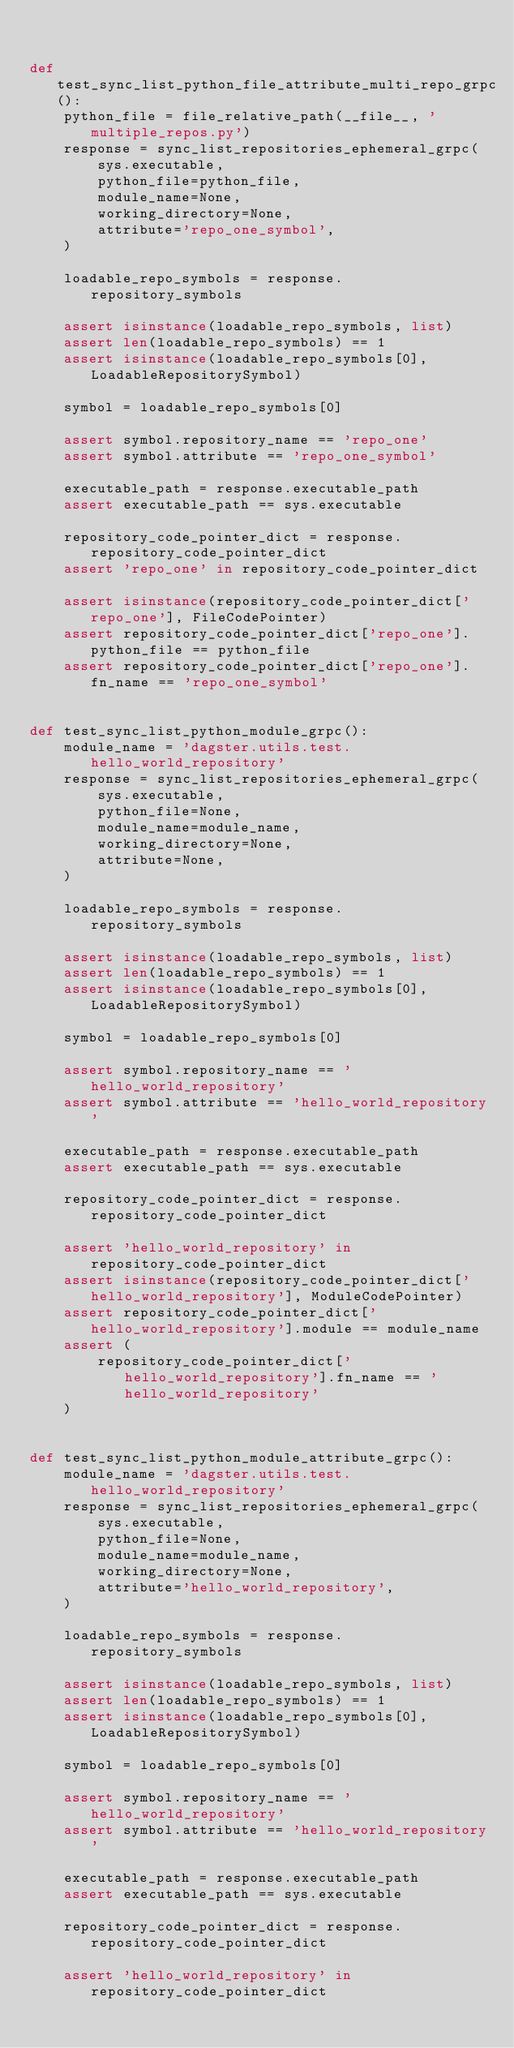Convert code to text. <code><loc_0><loc_0><loc_500><loc_500><_Python_>

def test_sync_list_python_file_attribute_multi_repo_grpc():
    python_file = file_relative_path(__file__, 'multiple_repos.py')
    response = sync_list_repositories_ephemeral_grpc(
        sys.executable,
        python_file=python_file,
        module_name=None,
        working_directory=None,
        attribute='repo_one_symbol',
    )

    loadable_repo_symbols = response.repository_symbols

    assert isinstance(loadable_repo_symbols, list)
    assert len(loadable_repo_symbols) == 1
    assert isinstance(loadable_repo_symbols[0], LoadableRepositorySymbol)

    symbol = loadable_repo_symbols[0]

    assert symbol.repository_name == 'repo_one'
    assert symbol.attribute == 'repo_one_symbol'

    executable_path = response.executable_path
    assert executable_path == sys.executable

    repository_code_pointer_dict = response.repository_code_pointer_dict
    assert 'repo_one' in repository_code_pointer_dict

    assert isinstance(repository_code_pointer_dict['repo_one'], FileCodePointer)
    assert repository_code_pointer_dict['repo_one'].python_file == python_file
    assert repository_code_pointer_dict['repo_one'].fn_name == 'repo_one_symbol'


def test_sync_list_python_module_grpc():
    module_name = 'dagster.utils.test.hello_world_repository'
    response = sync_list_repositories_ephemeral_grpc(
        sys.executable,
        python_file=None,
        module_name=module_name,
        working_directory=None,
        attribute=None,
    )

    loadable_repo_symbols = response.repository_symbols

    assert isinstance(loadable_repo_symbols, list)
    assert len(loadable_repo_symbols) == 1
    assert isinstance(loadable_repo_symbols[0], LoadableRepositorySymbol)

    symbol = loadable_repo_symbols[0]

    assert symbol.repository_name == 'hello_world_repository'
    assert symbol.attribute == 'hello_world_repository'

    executable_path = response.executable_path
    assert executable_path == sys.executable

    repository_code_pointer_dict = response.repository_code_pointer_dict

    assert 'hello_world_repository' in repository_code_pointer_dict
    assert isinstance(repository_code_pointer_dict['hello_world_repository'], ModuleCodePointer)
    assert repository_code_pointer_dict['hello_world_repository'].module == module_name
    assert (
        repository_code_pointer_dict['hello_world_repository'].fn_name == 'hello_world_repository'
    )


def test_sync_list_python_module_attribute_grpc():
    module_name = 'dagster.utils.test.hello_world_repository'
    response = sync_list_repositories_ephemeral_grpc(
        sys.executable,
        python_file=None,
        module_name=module_name,
        working_directory=None,
        attribute='hello_world_repository',
    )

    loadable_repo_symbols = response.repository_symbols

    assert isinstance(loadable_repo_symbols, list)
    assert len(loadable_repo_symbols) == 1
    assert isinstance(loadable_repo_symbols[0], LoadableRepositorySymbol)

    symbol = loadable_repo_symbols[0]

    assert symbol.repository_name == 'hello_world_repository'
    assert symbol.attribute == 'hello_world_repository'

    executable_path = response.executable_path
    assert executable_path == sys.executable

    repository_code_pointer_dict = response.repository_code_pointer_dict

    assert 'hello_world_repository' in repository_code_pointer_dict</code> 